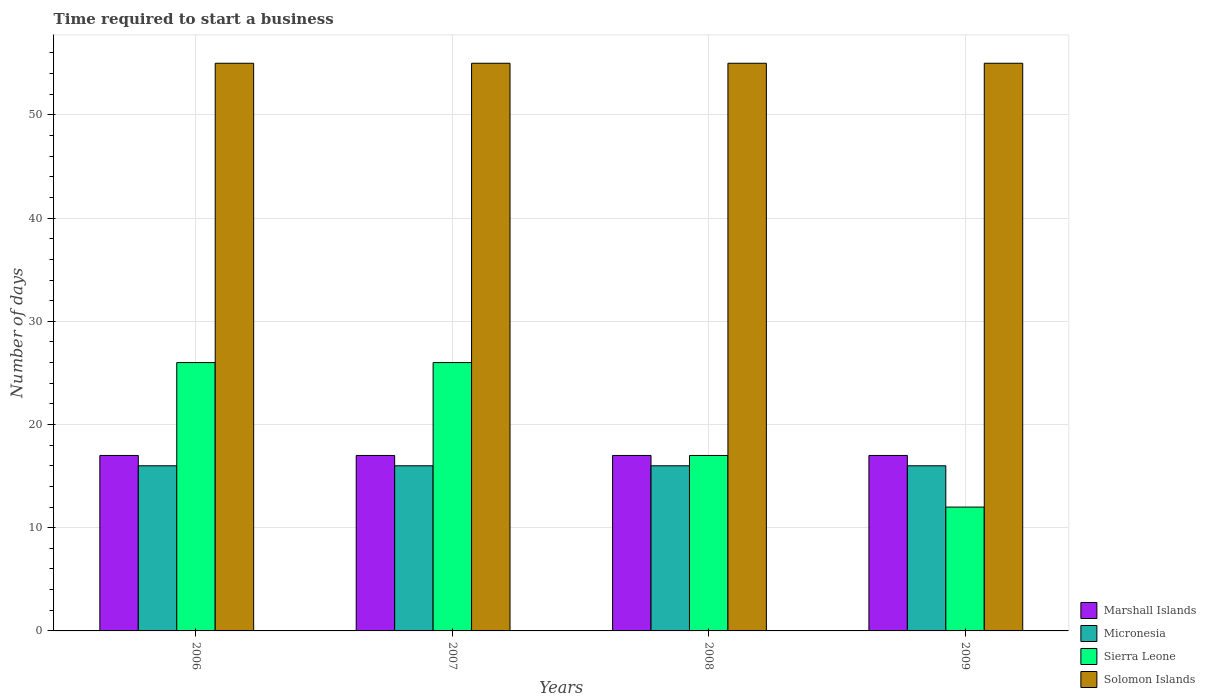How many groups of bars are there?
Offer a terse response. 4. Are the number of bars on each tick of the X-axis equal?
Provide a succinct answer. Yes. How many bars are there on the 3rd tick from the left?
Offer a terse response. 4. In how many cases, is the number of bars for a given year not equal to the number of legend labels?
Your response must be concise. 0. What is the number of days required to start a business in Sierra Leone in 2007?
Ensure brevity in your answer.  26. Across all years, what is the maximum number of days required to start a business in Micronesia?
Ensure brevity in your answer.  16. Across all years, what is the minimum number of days required to start a business in Micronesia?
Provide a short and direct response. 16. In which year was the number of days required to start a business in Solomon Islands maximum?
Give a very brief answer. 2006. What is the total number of days required to start a business in Solomon Islands in the graph?
Offer a very short reply. 220. What is the difference between the number of days required to start a business in Marshall Islands in 2007 and that in 2009?
Give a very brief answer. 0. What is the difference between the number of days required to start a business in Micronesia in 2008 and the number of days required to start a business in Solomon Islands in 2009?
Provide a succinct answer. -39. What is the average number of days required to start a business in Marshall Islands per year?
Keep it short and to the point. 17. In the year 2008, what is the difference between the number of days required to start a business in Sierra Leone and number of days required to start a business in Solomon Islands?
Make the answer very short. -38. In how many years, is the number of days required to start a business in Sierra Leone greater than 28 days?
Give a very brief answer. 0. What is the ratio of the number of days required to start a business in Sierra Leone in 2007 to that in 2008?
Your answer should be compact. 1.53. Is the number of days required to start a business in Solomon Islands in 2007 less than that in 2009?
Ensure brevity in your answer.  No. Is the difference between the number of days required to start a business in Sierra Leone in 2007 and 2009 greater than the difference between the number of days required to start a business in Solomon Islands in 2007 and 2009?
Your answer should be compact. Yes. What is the difference between the highest and the second highest number of days required to start a business in Sierra Leone?
Your response must be concise. 0. Is it the case that in every year, the sum of the number of days required to start a business in Micronesia and number of days required to start a business in Sierra Leone is greater than the sum of number of days required to start a business in Marshall Islands and number of days required to start a business in Solomon Islands?
Provide a succinct answer. No. What does the 4th bar from the left in 2006 represents?
Your answer should be very brief. Solomon Islands. What does the 4th bar from the right in 2007 represents?
Provide a short and direct response. Marshall Islands. Does the graph contain any zero values?
Your answer should be very brief. No. Where does the legend appear in the graph?
Keep it short and to the point. Bottom right. What is the title of the graph?
Provide a short and direct response. Time required to start a business. What is the label or title of the Y-axis?
Offer a very short reply. Number of days. What is the Number of days of Micronesia in 2006?
Your answer should be very brief. 16. What is the Number of days of Marshall Islands in 2007?
Provide a short and direct response. 17. What is the Number of days in Marshall Islands in 2008?
Keep it short and to the point. 17. What is the Number of days in Micronesia in 2008?
Your response must be concise. 16. What is the Number of days of Solomon Islands in 2008?
Offer a terse response. 55. What is the Number of days of Marshall Islands in 2009?
Make the answer very short. 17. What is the Number of days of Micronesia in 2009?
Your answer should be compact. 16. Across all years, what is the maximum Number of days in Sierra Leone?
Provide a short and direct response. 26. Across all years, what is the maximum Number of days in Solomon Islands?
Provide a short and direct response. 55. Across all years, what is the minimum Number of days of Marshall Islands?
Make the answer very short. 17. Across all years, what is the minimum Number of days of Micronesia?
Offer a very short reply. 16. Across all years, what is the minimum Number of days of Sierra Leone?
Keep it short and to the point. 12. Across all years, what is the minimum Number of days of Solomon Islands?
Provide a short and direct response. 55. What is the total Number of days of Marshall Islands in the graph?
Your answer should be very brief. 68. What is the total Number of days of Solomon Islands in the graph?
Offer a very short reply. 220. What is the difference between the Number of days of Marshall Islands in 2006 and that in 2007?
Make the answer very short. 0. What is the difference between the Number of days in Sierra Leone in 2006 and that in 2008?
Keep it short and to the point. 9. What is the difference between the Number of days in Marshall Islands in 2006 and that in 2009?
Your response must be concise. 0. What is the difference between the Number of days in Micronesia in 2006 and that in 2009?
Provide a succinct answer. 0. What is the difference between the Number of days in Solomon Islands in 2006 and that in 2009?
Provide a short and direct response. 0. What is the difference between the Number of days in Sierra Leone in 2007 and that in 2008?
Your response must be concise. 9. What is the difference between the Number of days in Sierra Leone in 2007 and that in 2009?
Keep it short and to the point. 14. What is the difference between the Number of days of Marshall Islands in 2006 and the Number of days of Solomon Islands in 2007?
Provide a short and direct response. -38. What is the difference between the Number of days in Micronesia in 2006 and the Number of days in Sierra Leone in 2007?
Your answer should be compact. -10. What is the difference between the Number of days of Micronesia in 2006 and the Number of days of Solomon Islands in 2007?
Keep it short and to the point. -39. What is the difference between the Number of days of Marshall Islands in 2006 and the Number of days of Micronesia in 2008?
Provide a succinct answer. 1. What is the difference between the Number of days of Marshall Islands in 2006 and the Number of days of Sierra Leone in 2008?
Make the answer very short. 0. What is the difference between the Number of days in Marshall Islands in 2006 and the Number of days in Solomon Islands in 2008?
Keep it short and to the point. -38. What is the difference between the Number of days of Micronesia in 2006 and the Number of days of Solomon Islands in 2008?
Give a very brief answer. -39. What is the difference between the Number of days of Marshall Islands in 2006 and the Number of days of Solomon Islands in 2009?
Your answer should be very brief. -38. What is the difference between the Number of days in Micronesia in 2006 and the Number of days in Solomon Islands in 2009?
Give a very brief answer. -39. What is the difference between the Number of days in Sierra Leone in 2006 and the Number of days in Solomon Islands in 2009?
Your response must be concise. -29. What is the difference between the Number of days of Marshall Islands in 2007 and the Number of days of Sierra Leone in 2008?
Offer a very short reply. 0. What is the difference between the Number of days of Marshall Islands in 2007 and the Number of days of Solomon Islands in 2008?
Ensure brevity in your answer.  -38. What is the difference between the Number of days in Micronesia in 2007 and the Number of days in Sierra Leone in 2008?
Offer a terse response. -1. What is the difference between the Number of days of Micronesia in 2007 and the Number of days of Solomon Islands in 2008?
Offer a terse response. -39. What is the difference between the Number of days of Marshall Islands in 2007 and the Number of days of Sierra Leone in 2009?
Your answer should be very brief. 5. What is the difference between the Number of days of Marshall Islands in 2007 and the Number of days of Solomon Islands in 2009?
Your answer should be compact. -38. What is the difference between the Number of days in Micronesia in 2007 and the Number of days in Sierra Leone in 2009?
Provide a succinct answer. 4. What is the difference between the Number of days of Micronesia in 2007 and the Number of days of Solomon Islands in 2009?
Give a very brief answer. -39. What is the difference between the Number of days of Marshall Islands in 2008 and the Number of days of Micronesia in 2009?
Your answer should be compact. 1. What is the difference between the Number of days of Marshall Islands in 2008 and the Number of days of Solomon Islands in 2009?
Offer a terse response. -38. What is the difference between the Number of days in Micronesia in 2008 and the Number of days in Sierra Leone in 2009?
Your response must be concise. 4. What is the difference between the Number of days of Micronesia in 2008 and the Number of days of Solomon Islands in 2009?
Your answer should be very brief. -39. What is the difference between the Number of days of Sierra Leone in 2008 and the Number of days of Solomon Islands in 2009?
Your response must be concise. -38. What is the average Number of days of Marshall Islands per year?
Offer a very short reply. 17. What is the average Number of days in Micronesia per year?
Provide a short and direct response. 16. What is the average Number of days of Sierra Leone per year?
Offer a terse response. 20.25. What is the average Number of days of Solomon Islands per year?
Your answer should be compact. 55. In the year 2006, what is the difference between the Number of days in Marshall Islands and Number of days in Sierra Leone?
Offer a very short reply. -9. In the year 2006, what is the difference between the Number of days of Marshall Islands and Number of days of Solomon Islands?
Provide a short and direct response. -38. In the year 2006, what is the difference between the Number of days of Micronesia and Number of days of Solomon Islands?
Offer a very short reply. -39. In the year 2007, what is the difference between the Number of days of Marshall Islands and Number of days of Micronesia?
Offer a terse response. 1. In the year 2007, what is the difference between the Number of days of Marshall Islands and Number of days of Solomon Islands?
Offer a very short reply. -38. In the year 2007, what is the difference between the Number of days of Micronesia and Number of days of Sierra Leone?
Ensure brevity in your answer.  -10. In the year 2007, what is the difference between the Number of days of Micronesia and Number of days of Solomon Islands?
Your response must be concise. -39. In the year 2008, what is the difference between the Number of days of Marshall Islands and Number of days of Sierra Leone?
Provide a short and direct response. 0. In the year 2008, what is the difference between the Number of days in Marshall Islands and Number of days in Solomon Islands?
Offer a terse response. -38. In the year 2008, what is the difference between the Number of days in Micronesia and Number of days in Solomon Islands?
Give a very brief answer. -39. In the year 2008, what is the difference between the Number of days of Sierra Leone and Number of days of Solomon Islands?
Provide a succinct answer. -38. In the year 2009, what is the difference between the Number of days of Marshall Islands and Number of days of Micronesia?
Make the answer very short. 1. In the year 2009, what is the difference between the Number of days in Marshall Islands and Number of days in Solomon Islands?
Give a very brief answer. -38. In the year 2009, what is the difference between the Number of days of Micronesia and Number of days of Solomon Islands?
Offer a terse response. -39. In the year 2009, what is the difference between the Number of days of Sierra Leone and Number of days of Solomon Islands?
Your response must be concise. -43. What is the ratio of the Number of days of Marshall Islands in 2006 to that in 2007?
Make the answer very short. 1. What is the ratio of the Number of days in Micronesia in 2006 to that in 2007?
Keep it short and to the point. 1. What is the ratio of the Number of days of Marshall Islands in 2006 to that in 2008?
Your answer should be compact. 1. What is the ratio of the Number of days of Sierra Leone in 2006 to that in 2008?
Offer a very short reply. 1.53. What is the ratio of the Number of days of Solomon Islands in 2006 to that in 2008?
Your response must be concise. 1. What is the ratio of the Number of days in Micronesia in 2006 to that in 2009?
Provide a succinct answer. 1. What is the ratio of the Number of days of Sierra Leone in 2006 to that in 2009?
Keep it short and to the point. 2.17. What is the ratio of the Number of days of Marshall Islands in 2007 to that in 2008?
Make the answer very short. 1. What is the ratio of the Number of days of Micronesia in 2007 to that in 2008?
Ensure brevity in your answer.  1. What is the ratio of the Number of days of Sierra Leone in 2007 to that in 2008?
Provide a short and direct response. 1.53. What is the ratio of the Number of days of Marshall Islands in 2007 to that in 2009?
Keep it short and to the point. 1. What is the ratio of the Number of days in Sierra Leone in 2007 to that in 2009?
Keep it short and to the point. 2.17. What is the ratio of the Number of days of Solomon Islands in 2007 to that in 2009?
Offer a very short reply. 1. What is the ratio of the Number of days in Marshall Islands in 2008 to that in 2009?
Offer a terse response. 1. What is the ratio of the Number of days in Sierra Leone in 2008 to that in 2009?
Provide a short and direct response. 1.42. What is the difference between the highest and the second highest Number of days of Marshall Islands?
Your answer should be compact. 0. What is the difference between the highest and the second highest Number of days of Micronesia?
Your response must be concise. 0. What is the difference between the highest and the second highest Number of days of Sierra Leone?
Offer a very short reply. 0. What is the difference between the highest and the lowest Number of days in Micronesia?
Your answer should be compact. 0. What is the difference between the highest and the lowest Number of days in Solomon Islands?
Your response must be concise. 0. 